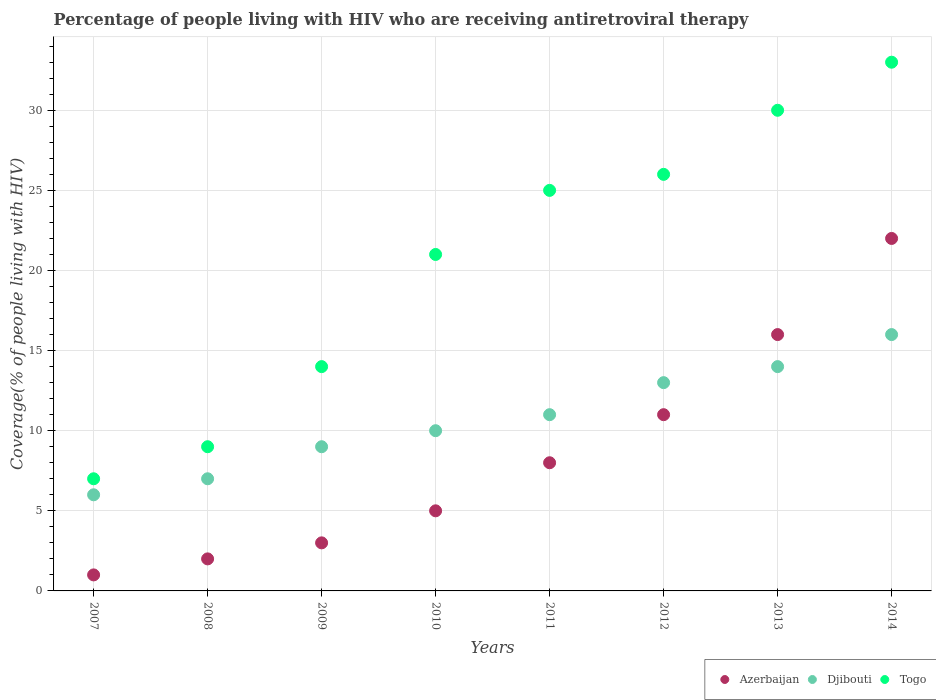How many different coloured dotlines are there?
Provide a succinct answer. 3. Is the number of dotlines equal to the number of legend labels?
Offer a terse response. Yes. What is the percentage of the HIV infected people who are receiving antiretroviral therapy in Djibouti in 2011?
Provide a succinct answer. 11. Across all years, what is the maximum percentage of the HIV infected people who are receiving antiretroviral therapy in Azerbaijan?
Provide a succinct answer. 22. Across all years, what is the minimum percentage of the HIV infected people who are receiving antiretroviral therapy in Azerbaijan?
Offer a terse response. 1. In which year was the percentage of the HIV infected people who are receiving antiretroviral therapy in Djibouti maximum?
Ensure brevity in your answer.  2014. What is the total percentage of the HIV infected people who are receiving antiretroviral therapy in Azerbaijan in the graph?
Your answer should be very brief. 68. What is the difference between the percentage of the HIV infected people who are receiving antiretroviral therapy in Djibouti in 2007 and that in 2014?
Your answer should be very brief. -10. What is the difference between the percentage of the HIV infected people who are receiving antiretroviral therapy in Djibouti in 2010 and the percentage of the HIV infected people who are receiving antiretroviral therapy in Togo in 2007?
Ensure brevity in your answer.  3. What is the average percentage of the HIV infected people who are receiving antiretroviral therapy in Togo per year?
Offer a very short reply. 20.62. In the year 2007, what is the difference between the percentage of the HIV infected people who are receiving antiretroviral therapy in Togo and percentage of the HIV infected people who are receiving antiretroviral therapy in Djibouti?
Your answer should be compact. 1. In how many years, is the percentage of the HIV infected people who are receiving antiretroviral therapy in Azerbaijan greater than 31 %?
Your answer should be very brief. 0. What is the ratio of the percentage of the HIV infected people who are receiving antiretroviral therapy in Djibouti in 2007 to that in 2008?
Provide a short and direct response. 0.86. Is the percentage of the HIV infected people who are receiving antiretroviral therapy in Togo in 2009 less than that in 2010?
Give a very brief answer. Yes. Is the difference between the percentage of the HIV infected people who are receiving antiretroviral therapy in Togo in 2009 and 2010 greater than the difference between the percentage of the HIV infected people who are receiving antiretroviral therapy in Djibouti in 2009 and 2010?
Keep it short and to the point. No. What is the difference between the highest and the lowest percentage of the HIV infected people who are receiving antiretroviral therapy in Djibouti?
Give a very brief answer. 10. In how many years, is the percentage of the HIV infected people who are receiving antiretroviral therapy in Togo greater than the average percentage of the HIV infected people who are receiving antiretroviral therapy in Togo taken over all years?
Your answer should be very brief. 5. Is it the case that in every year, the sum of the percentage of the HIV infected people who are receiving antiretroviral therapy in Djibouti and percentage of the HIV infected people who are receiving antiretroviral therapy in Azerbaijan  is greater than the percentage of the HIV infected people who are receiving antiretroviral therapy in Togo?
Your response must be concise. No. Does the percentage of the HIV infected people who are receiving antiretroviral therapy in Azerbaijan monotonically increase over the years?
Your answer should be compact. Yes. Does the graph contain any zero values?
Give a very brief answer. No. Where does the legend appear in the graph?
Ensure brevity in your answer.  Bottom right. How many legend labels are there?
Provide a succinct answer. 3. What is the title of the graph?
Give a very brief answer. Percentage of people living with HIV who are receiving antiretroviral therapy. What is the label or title of the X-axis?
Make the answer very short. Years. What is the label or title of the Y-axis?
Provide a short and direct response. Coverage(% of people living with HIV). What is the Coverage(% of people living with HIV) in Djibouti in 2007?
Provide a succinct answer. 6. What is the Coverage(% of people living with HIV) of Azerbaijan in 2008?
Your answer should be very brief. 2. What is the Coverage(% of people living with HIV) of Togo in 2008?
Offer a very short reply. 9. What is the Coverage(% of people living with HIV) in Azerbaijan in 2009?
Your answer should be very brief. 3. What is the Coverage(% of people living with HIV) in Togo in 2009?
Give a very brief answer. 14. What is the Coverage(% of people living with HIV) in Azerbaijan in 2011?
Offer a very short reply. 8. What is the Coverage(% of people living with HIV) of Togo in 2011?
Give a very brief answer. 25. What is the Coverage(% of people living with HIV) of Togo in 2012?
Keep it short and to the point. 26. What is the Coverage(% of people living with HIV) of Azerbaijan in 2013?
Provide a succinct answer. 16. What is the Coverage(% of people living with HIV) in Djibouti in 2013?
Your answer should be compact. 14. Across all years, what is the maximum Coverage(% of people living with HIV) of Djibouti?
Provide a short and direct response. 16. Across all years, what is the minimum Coverage(% of people living with HIV) of Djibouti?
Offer a very short reply. 6. What is the total Coverage(% of people living with HIV) in Togo in the graph?
Offer a terse response. 165. What is the difference between the Coverage(% of people living with HIV) of Djibouti in 2007 and that in 2008?
Offer a very short reply. -1. What is the difference between the Coverage(% of people living with HIV) in Togo in 2007 and that in 2008?
Give a very brief answer. -2. What is the difference between the Coverage(% of people living with HIV) of Djibouti in 2007 and that in 2009?
Provide a short and direct response. -3. What is the difference between the Coverage(% of people living with HIV) in Djibouti in 2007 and that in 2010?
Offer a terse response. -4. What is the difference between the Coverage(% of people living with HIV) of Togo in 2007 and that in 2010?
Your answer should be compact. -14. What is the difference between the Coverage(% of people living with HIV) of Djibouti in 2007 and that in 2014?
Keep it short and to the point. -10. What is the difference between the Coverage(% of people living with HIV) of Djibouti in 2008 and that in 2009?
Provide a short and direct response. -2. What is the difference between the Coverage(% of people living with HIV) of Togo in 2008 and that in 2010?
Make the answer very short. -12. What is the difference between the Coverage(% of people living with HIV) of Azerbaijan in 2008 and that in 2011?
Your answer should be compact. -6. What is the difference between the Coverage(% of people living with HIV) in Togo in 2008 and that in 2011?
Provide a succinct answer. -16. What is the difference between the Coverage(% of people living with HIV) of Azerbaijan in 2008 and that in 2012?
Your answer should be compact. -9. What is the difference between the Coverage(% of people living with HIV) of Azerbaijan in 2008 and that in 2013?
Offer a very short reply. -14. What is the difference between the Coverage(% of people living with HIV) in Azerbaijan in 2009 and that in 2010?
Ensure brevity in your answer.  -2. What is the difference between the Coverage(% of people living with HIV) of Togo in 2009 and that in 2010?
Give a very brief answer. -7. What is the difference between the Coverage(% of people living with HIV) in Azerbaijan in 2009 and that in 2012?
Make the answer very short. -8. What is the difference between the Coverage(% of people living with HIV) in Djibouti in 2009 and that in 2012?
Provide a short and direct response. -4. What is the difference between the Coverage(% of people living with HIV) of Azerbaijan in 2009 and that in 2014?
Make the answer very short. -19. What is the difference between the Coverage(% of people living with HIV) of Togo in 2009 and that in 2014?
Keep it short and to the point. -19. What is the difference between the Coverage(% of people living with HIV) of Azerbaijan in 2010 and that in 2011?
Provide a succinct answer. -3. What is the difference between the Coverage(% of people living with HIV) of Djibouti in 2010 and that in 2011?
Give a very brief answer. -1. What is the difference between the Coverage(% of people living with HIV) of Togo in 2010 and that in 2011?
Offer a very short reply. -4. What is the difference between the Coverage(% of people living with HIV) of Djibouti in 2010 and that in 2012?
Provide a short and direct response. -3. What is the difference between the Coverage(% of people living with HIV) in Togo in 2010 and that in 2012?
Make the answer very short. -5. What is the difference between the Coverage(% of people living with HIV) of Azerbaijan in 2010 and that in 2013?
Offer a very short reply. -11. What is the difference between the Coverage(% of people living with HIV) in Djibouti in 2010 and that in 2013?
Provide a succinct answer. -4. What is the difference between the Coverage(% of people living with HIV) of Togo in 2010 and that in 2014?
Ensure brevity in your answer.  -12. What is the difference between the Coverage(% of people living with HIV) of Azerbaijan in 2011 and that in 2012?
Offer a terse response. -3. What is the difference between the Coverage(% of people living with HIV) of Togo in 2011 and that in 2012?
Ensure brevity in your answer.  -1. What is the difference between the Coverage(% of people living with HIV) in Djibouti in 2011 and that in 2013?
Ensure brevity in your answer.  -3. What is the difference between the Coverage(% of people living with HIV) in Azerbaijan in 2011 and that in 2014?
Make the answer very short. -14. What is the difference between the Coverage(% of people living with HIV) of Togo in 2011 and that in 2014?
Provide a short and direct response. -8. What is the difference between the Coverage(% of people living with HIV) in Azerbaijan in 2012 and that in 2014?
Provide a succinct answer. -11. What is the difference between the Coverage(% of people living with HIV) of Togo in 2012 and that in 2014?
Offer a very short reply. -7. What is the difference between the Coverage(% of people living with HIV) in Azerbaijan in 2013 and that in 2014?
Offer a very short reply. -6. What is the difference between the Coverage(% of people living with HIV) of Togo in 2013 and that in 2014?
Make the answer very short. -3. What is the difference between the Coverage(% of people living with HIV) of Azerbaijan in 2007 and the Coverage(% of people living with HIV) of Djibouti in 2008?
Your answer should be very brief. -6. What is the difference between the Coverage(% of people living with HIV) in Azerbaijan in 2007 and the Coverage(% of people living with HIV) in Djibouti in 2009?
Offer a very short reply. -8. What is the difference between the Coverage(% of people living with HIV) of Azerbaijan in 2007 and the Coverage(% of people living with HIV) of Togo in 2009?
Your response must be concise. -13. What is the difference between the Coverage(% of people living with HIV) of Djibouti in 2007 and the Coverage(% of people living with HIV) of Togo in 2009?
Ensure brevity in your answer.  -8. What is the difference between the Coverage(% of people living with HIV) in Azerbaijan in 2007 and the Coverage(% of people living with HIV) in Djibouti in 2010?
Ensure brevity in your answer.  -9. What is the difference between the Coverage(% of people living with HIV) of Djibouti in 2007 and the Coverage(% of people living with HIV) of Togo in 2011?
Give a very brief answer. -19. What is the difference between the Coverage(% of people living with HIV) in Djibouti in 2007 and the Coverage(% of people living with HIV) in Togo in 2012?
Provide a short and direct response. -20. What is the difference between the Coverage(% of people living with HIV) in Azerbaijan in 2007 and the Coverage(% of people living with HIV) in Togo in 2013?
Offer a very short reply. -29. What is the difference between the Coverage(% of people living with HIV) in Djibouti in 2007 and the Coverage(% of people living with HIV) in Togo in 2013?
Your answer should be compact. -24. What is the difference between the Coverage(% of people living with HIV) in Azerbaijan in 2007 and the Coverage(% of people living with HIV) in Togo in 2014?
Offer a very short reply. -32. What is the difference between the Coverage(% of people living with HIV) of Azerbaijan in 2008 and the Coverage(% of people living with HIV) of Togo in 2009?
Give a very brief answer. -12. What is the difference between the Coverage(% of people living with HIV) in Azerbaijan in 2008 and the Coverage(% of people living with HIV) in Djibouti in 2011?
Your response must be concise. -9. What is the difference between the Coverage(% of people living with HIV) in Djibouti in 2008 and the Coverage(% of people living with HIV) in Togo in 2011?
Provide a short and direct response. -18. What is the difference between the Coverage(% of people living with HIV) of Djibouti in 2008 and the Coverage(% of people living with HIV) of Togo in 2012?
Offer a very short reply. -19. What is the difference between the Coverage(% of people living with HIV) in Djibouti in 2008 and the Coverage(% of people living with HIV) in Togo in 2013?
Your answer should be compact. -23. What is the difference between the Coverage(% of people living with HIV) in Azerbaijan in 2008 and the Coverage(% of people living with HIV) in Togo in 2014?
Your answer should be very brief. -31. What is the difference between the Coverage(% of people living with HIV) of Djibouti in 2008 and the Coverage(% of people living with HIV) of Togo in 2014?
Offer a terse response. -26. What is the difference between the Coverage(% of people living with HIV) of Azerbaijan in 2009 and the Coverage(% of people living with HIV) of Djibouti in 2011?
Your response must be concise. -8. What is the difference between the Coverage(% of people living with HIV) in Azerbaijan in 2009 and the Coverage(% of people living with HIV) in Togo in 2011?
Your answer should be compact. -22. What is the difference between the Coverage(% of people living with HIV) of Azerbaijan in 2009 and the Coverage(% of people living with HIV) of Togo in 2012?
Keep it short and to the point. -23. What is the difference between the Coverage(% of people living with HIV) in Azerbaijan in 2009 and the Coverage(% of people living with HIV) in Djibouti in 2013?
Provide a succinct answer. -11. What is the difference between the Coverage(% of people living with HIV) in Azerbaijan in 2009 and the Coverage(% of people living with HIV) in Togo in 2013?
Provide a succinct answer. -27. What is the difference between the Coverage(% of people living with HIV) in Azerbaijan in 2009 and the Coverage(% of people living with HIV) in Djibouti in 2014?
Offer a very short reply. -13. What is the difference between the Coverage(% of people living with HIV) of Azerbaijan in 2009 and the Coverage(% of people living with HIV) of Togo in 2014?
Your answer should be compact. -30. What is the difference between the Coverage(% of people living with HIV) in Azerbaijan in 2010 and the Coverage(% of people living with HIV) in Djibouti in 2011?
Give a very brief answer. -6. What is the difference between the Coverage(% of people living with HIV) of Azerbaijan in 2010 and the Coverage(% of people living with HIV) of Togo in 2011?
Give a very brief answer. -20. What is the difference between the Coverage(% of people living with HIV) of Djibouti in 2010 and the Coverage(% of people living with HIV) of Togo in 2011?
Ensure brevity in your answer.  -15. What is the difference between the Coverage(% of people living with HIV) of Azerbaijan in 2010 and the Coverage(% of people living with HIV) of Djibouti in 2012?
Offer a terse response. -8. What is the difference between the Coverage(% of people living with HIV) in Djibouti in 2010 and the Coverage(% of people living with HIV) in Togo in 2012?
Your answer should be very brief. -16. What is the difference between the Coverage(% of people living with HIV) of Djibouti in 2010 and the Coverage(% of people living with HIV) of Togo in 2013?
Your response must be concise. -20. What is the difference between the Coverage(% of people living with HIV) in Azerbaijan in 2010 and the Coverage(% of people living with HIV) in Djibouti in 2014?
Offer a very short reply. -11. What is the difference between the Coverage(% of people living with HIV) of Azerbaijan in 2010 and the Coverage(% of people living with HIV) of Togo in 2014?
Give a very brief answer. -28. What is the difference between the Coverage(% of people living with HIV) in Djibouti in 2010 and the Coverage(% of people living with HIV) in Togo in 2014?
Provide a short and direct response. -23. What is the difference between the Coverage(% of people living with HIV) in Azerbaijan in 2011 and the Coverage(% of people living with HIV) in Djibouti in 2012?
Your answer should be compact. -5. What is the difference between the Coverage(% of people living with HIV) of Azerbaijan in 2011 and the Coverage(% of people living with HIV) of Togo in 2012?
Provide a short and direct response. -18. What is the difference between the Coverage(% of people living with HIV) in Djibouti in 2011 and the Coverage(% of people living with HIV) in Togo in 2012?
Your answer should be compact. -15. What is the difference between the Coverage(% of people living with HIV) in Djibouti in 2011 and the Coverage(% of people living with HIV) in Togo in 2013?
Offer a very short reply. -19. What is the difference between the Coverage(% of people living with HIV) of Azerbaijan in 2011 and the Coverage(% of people living with HIV) of Djibouti in 2014?
Provide a succinct answer. -8. What is the difference between the Coverage(% of people living with HIV) in Azerbaijan in 2011 and the Coverage(% of people living with HIV) in Togo in 2014?
Keep it short and to the point. -25. What is the difference between the Coverage(% of people living with HIV) of Djibouti in 2011 and the Coverage(% of people living with HIV) of Togo in 2014?
Provide a short and direct response. -22. What is the difference between the Coverage(% of people living with HIV) in Azerbaijan in 2012 and the Coverage(% of people living with HIV) in Djibouti in 2013?
Keep it short and to the point. -3. What is the difference between the Coverage(% of people living with HIV) of Djibouti in 2012 and the Coverage(% of people living with HIV) of Togo in 2014?
Your answer should be compact. -20. What is the difference between the Coverage(% of people living with HIV) in Azerbaijan in 2013 and the Coverage(% of people living with HIV) in Togo in 2014?
Make the answer very short. -17. What is the average Coverage(% of people living with HIV) in Azerbaijan per year?
Offer a terse response. 8.5. What is the average Coverage(% of people living with HIV) of Djibouti per year?
Offer a terse response. 10.75. What is the average Coverage(% of people living with HIV) of Togo per year?
Keep it short and to the point. 20.62. In the year 2007, what is the difference between the Coverage(% of people living with HIV) of Azerbaijan and Coverage(% of people living with HIV) of Djibouti?
Make the answer very short. -5. In the year 2007, what is the difference between the Coverage(% of people living with HIV) of Djibouti and Coverage(% of people living with HIV) of Togo?
Your response must be concise. -1. In the year 2009, what is the difference between the Coverage(% of people living with HIV) in Djibouti and Coverage(% of people living with HIV) in Togo?
Offer a terse response. -5. In the year 2010, what is the difference between the Coverage(% of people living with HIV) of Azerbaijan and Coverage(% of people living with HIV) of Djibouti?
Your response must be concise. -5. In the year 2010, what is the difference between the Coverage(% of people living with HIV) of Azerbaijan and Coverage(% of people living with HIV) of Togo?
Make the answer very short. -16. In the year 2010, what is the difference between the Coverage(% of people living with HIV) of Djibouti and Coverage(% of people living with HIV) of Togo?
Offer a terse response. -11. In the year 2011, what is the difference between the Coverage(% of people living with HIV) of Azerbaijan and Coverage(% of people living with HIV) of Djibouti?
Offer a very short reply. -3. In the year 2011, what is the difference between the Coverage(% of people living with HIV) in Azerbaijan and Coverage(% of people living with HIV) in Togo?
Offer a very short reply. -17. In the year 2011, what is the difference between the Coverage(% of people living with HIV) in Djibouti and Coverage(% of people living with HIV) in Togo?
Make the answer very short. -14. In the year 2012, what is the difference between the Coverage(% of people living with HIV) of Azerbaijan and Coverage(% of people living with HIV) of Djibouti?
Provide a succinct answer. -2. In the year 2012, what is the difference between the Coverage(% of people living with HIV) of Azerbaijan and Coverage(% of people living with HIV) of Togo?
Your response must be concise. -15. In the year 2013, what is the difference between the Coverage(% of people living with HIV) in Azerbaijan and Coverage(% of people living with HIV) in Djibouti?
Ensure brevity in your answer.  2. In the year 2013, what is the difference between the Coverage(% of people living with HIV) of Azerbaijan and Coverage(% of people living with HIV) of Togo?
Offer a terse response. -14. In the year 2013, what is the difference between the Coverage(% of people living with HIV) in Djibouti and Coverage(% of people living with HIV) in Togo?
Ensure brevity in your answer.  -16. In the year 2014, what is the difference between the Coverage(% of people living with HIV) of Azerbaijan and Coverage(% of people living with HIV) of Djibouti?
Offer a terse response. 6. In the year 2014, what is the difference between the Coverage(% of people living with HIV) of Djibouti and Coverage(% of people living with HIV) of Togo?
Give a very brief answer. -17. What is the ratio of the Coverage(% of people living with HIV) in Togo in 2007 to that in 2008?
Keep it short and to the point. 0.78. What is the ratio of the Coverage(% of people living with HIV) of Togo in 2007 to that in 2009?
Offer a terse response. 0.5. What is the ratio of the Coverage(% of people living with HIV) in Azerbaijan in 2007 to that in 2010?
Provide a short and direct response. 0.2. What is the ratio of the Coverage(% of people living with HIV) in Togo in 2007 to that in 2010?
Give a very brief answer. 0.33. What is the ratio of the Coverage(% of people living with HIV) in Djibouti in 2007 to that in 2011?
Your response must be concise. 0.55. What is the ratio of the Coverage(% of people living with HIV) of Togo in 2007 to that in 2011?
Make the answer very short. 0.28. What is the ratio of the Coverage(% of people living with HIV) in Azerbaijan in 2007 to that in 2012?
Your answer should be very brief. 0.09. What is the ratio of the Coverage(% of people living with HIV) in Djibouti in 2007 to that in 2012?
Your answer should be very brief. 0.46. What is the ratio of the Coverage(% of people living with HIV) in Togo in 2007 to that in 2012?
Keep it short and to the point. 0.27. What is the ratio of the Coverage(% of people living with HIV) of Azerbaijan in 2007 to that in 2013?
Your answer should be compact. 0.06. What is the ratio of the Coverage(% of people living with HIV) in Djibouti in 2007 to that in 2013?
Give a very brief answer. 0.43. What is the ratio of the Coverage(% of people living with HIV) of Togo in 2007 to that in 2013?
Your answer should be compact. 0.23. What is the ratio of the Coverage(% of people living with HIV) in Azerbaijan in 2007 to that in 2014?
Provide a succinct answer. 0.05. What is the ratio of the Coverage(% of people living with HIV) in Togo in 2007 to that in 2014?
Ensure brevity in your answer.  0.21. What is the ratio of the Coverage(% of people living with HIV) in Djibouti in 2008 to that in 2009?
Provide a succinct answer. 0.78. What is the ratio of the Coverage(% of people living with HIV) of Togo in 2008 to that in 2009?
Ensure brevity in your answer.  0.64. What is the ratio of the Coverage(% of people living with HIV) in Azerbaijan in 2008 to that in 2010?
Give a very brief answer. 0.4. What is the ratio of the Coverage(% of people living with HIV) of Djibouti in 2008 to that in 2010?
Make the answer very short. 0.7. What is the ratio of the Coverage(% of people living with HIV) of Togo in 2008 to that in 2010?
Your response must be concise. 0.43. What is the ratio of the Coverage(% of people living with HIV) in Djibouti in 2008 to that in 2011?
Your answer should be compact. 0.64. What is the ratio of the Coverage(% of people living with HIV) in Togo in 2008 to that in 2011?
Provide a succinct answer. 0.36. What is the ratio of the Coverage(% of people living with HIV) in Azerbaijan in 2008 to that in 2012?
Keep it short and to the point. 0.18. What is the ratio of the Coverage(% of people living with HIV) of Djibouti in 2008 to that in 2012?
Ensure brevity in your answer.  0.54. What is the ratio of the Coverage(% of people living with HIV) of Togo in 2008 to that in 2012?
Your answer should be compact. 0.35. What is the ratio of the Coverage(% of people living with HIV) in Azerbaijan in 2008 to that in 2014?
Provide a short and direct response. 0.09. What is the ratio of the Coverage(% of people living with HIV) of Djibouti in 2008 to that in 2014?
Make the answer very short. 0.44. What is the ratio of the Coverage(% of people living with HIV) of Togo in 2008 to that in 2014?
Your response must be concise. 0.27. What is the ratio of the Coverage(% of people living with HIV) of Azerbaijan in 2009 to that in 2010?
Make the answer very short. 0.6. What is the ratio of the Coverage(% of people living with HIV) of Togo in 2009 to that in 2010?
Offer a terse response. 0.67. What is the ratio of the Coverage(% of people living with HIV) in Djibouti in 2009 to that in 2011?
Keep it short and to the point. 0.82. What is the ratio of the Coverage(% of people living with HIV) of Togo in 2009 to that in 2011?
Your answer should be compact. 0.56. What is the ratio of the Coverage(% of people living with HIV) of Azerbaijan in 2009 to that in 2012?
Keep it short and to the point. 0.27. What is the ratio of the Coverage(% of people living with HIV) of Djibouti in 2009 to that in 2012?
Keep it short and to the point. 0.69. What is the ratio of the Coverage(% of people living with HIV) of Togo in 2009 to that in 2012?
Your answer should be very brief. 0.54. What is the ratio of the Coverage(% of people living with HIV) of Azerbaijan in 2009 to that in 2013?
Make the answer very short. 0.19. What is the ratio of the Coverage(% of people living with HIV) in Djibouti in 2009 to that in 2013?
Offer a very short reply. 0.64. What is the ratio of the Coverage(% of people living with HIV) of Togo in 2009 to that in 2013?
Keep it short and to the point. 0.47. What is the ratio of the Coverage(% of people living with HIV) in Azerbaijan in 2009 to that in 2014?
Make the answer very short. 0.14. What is the ratio of the Coverage(% of people living with HIV) of Djibouti in 2009 to that in 2014?
Provide a succinct answer. 0.56. What is the ratio of the Coverage(% of people living with HIV) in Togo in 2009 to that in 2014?
Your answer should be very brief. 0.42. What is the ratio of the Coverage(% of people living with HIV) of Azerbaijan in 2010 to that in 2011?
Ensure brevity in your answer.  0.62. What is the ratio of the Coverage(% of people living with HIV) in Djibouti in 2010 to that in 2011?
Your response must be concise. 0.91. What is the ratio of the Coverage(% of people living with HIV) of Togo in 2010 to that in 2011?
Ensure brevity in your answer.  0.84. What is the ratio of the Coverage(% of people living with HIV) of Azerbaijan in 2010 to that in 2012?
Your response must be concise. 0.45. What is the ratio of the Coverage(% of people living with HIV) of Djibouti in 2010 to that in 2012?
Your answer should be compact. 0.77. What is the ratio of the Coverage(% of people living with HIV) in Togo in 2010 to that in 2012?
Provide a short and direct response. 0.81. What is the ratio of the Coverage(% of people living with HIV) in Azerbaijan in 2010 to that in 2013?
Give a very brief answer. 0.31. What is the ratio of the Coverage(% of people living with HIV) in Djibouti in 2010 to that in 2013?
Make the answer very short. 0.71. What is the ratio of the Coverage(% of people living with HIV) in Togo in 2010 to that in 2013?
Your answer should be compact. 0.7. What is the ratio of the Coverage(% of people living with HIV) in Azerbaijan in 2010 to that in 2014?
Keep it short and to the point. 0.23. What is the ratio of the Coverage(% of people living with HIV) of Togo in 2010 to that in 2014?
Give a very brief answer. 0.64. What is the ratio of the Coverage(% of people living with HIV) of Azerbaijan in 2011 to that in 2012?
Offer a very short reply. 0.73. What is the ratio of the Coverage(% of people living with HIV) in Djibouti in 2011 to that in 2012?
Keep it short and to the point. 0.85. What is the ratio of the Coverage(% of people living with HIV) in Togo in 2011 to that in 2012?
Your answer should be compact. 0.96. What is the ratio of the Coverage(% of people living with HIV) in Azerbaijan in 2011 to that in 2013?
Your answer should be compact. 0.5. What is the ratio of the Coverage(% of people living with HIV) in Djibouti in 2011 to that in 2013?
Offer a terse response. 0.79. What is the ratio of the Coverage(% of people living with HIV) in Togo in 2011 to that in 2013?
Your response must be concise. 0.83. What is the ratio of the Coverage(% of people living with HIV) in Azerbaijan in 2011 to that in 2014?
Give a very brief answer. 0.36. What is the ratio of the Coverage(% of people living with HIV) of Djibouti in 2011 to that in 2014?
Give a very brief answer. 0.69. What is the ratio of the Coverage(% of people living with HIV) in Togo in 2011 to that in 2014?
Offer a very short reply. 0.76. What is the ratio of the Coverage(% of people living with HIV) in Azerbaijan in 2012 to that in 2013?
Offer a very short reply. 0.69. What is the ratio of the Coverage(% of people living with HIV) of Djibouti in 2012 to that in 2013?
Offer a terse response. 0.93. What is the ratio of the Coverage(% of people living with HIV) in Togo in 2012 to that in 2013?
Make the answer very short. 0.87. What is the ratio of the Coverage(% of people living with HIV) of Djibouti in 2012 to that in 2014?
Offer a terse response. 0.81. What is the ratio of the Coverage(% of people living with HIV) in Togo in 2012 to that in 2014?
Provide a succinct answer. 0.79. What is the ratio of the Coverage(% of people living with HIV) of Azerbaijan in 2013 to that in 2014?
Your answer should be very brief. 0.73. What is the ratio of the Coverage(% of people living with HIV) of Togo in 2013 to that in 2014?
Offer a terse response. 0.91. What is the difference between the highest and the second highest Coverage(% of people living with HIV) in Azerbaijan?
Offer a terse response. 6. What is the difference between the highest and the lowest Coverage(% of people living with HIV) of Azerbaijan?
Offer a very short reply. 21. What is the difference between the highest and the lowest Coverage(% of people living with HIV) of Djibouti?
Give a very brief answer. 10. 